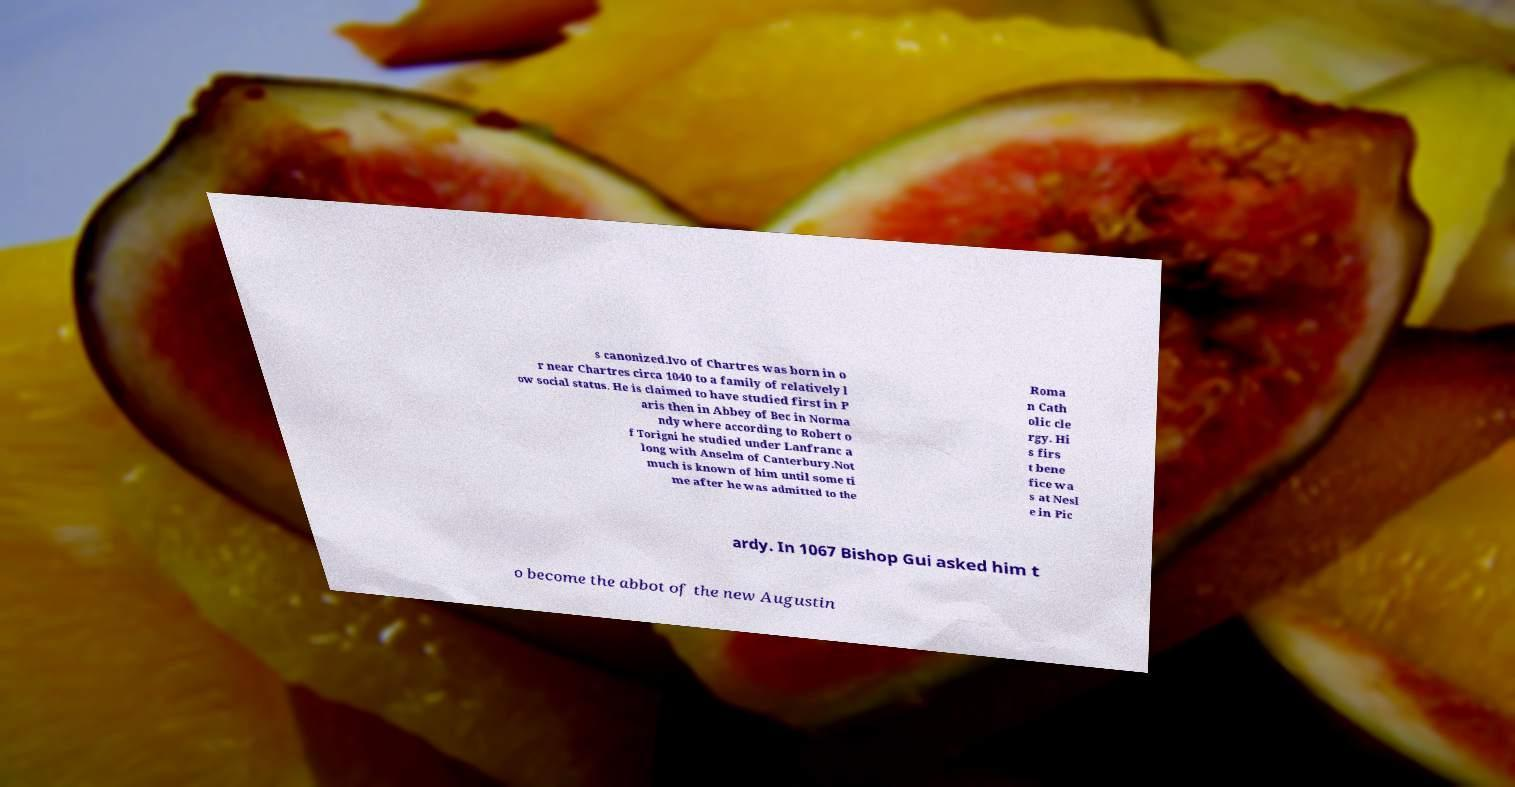Please identify and transcribe the text found in this image. s canonized.Ivo of Chartres was born in o r near Chartres circa 1040 to a family of relatively l ow social status. He is claimed to have studied first in P aris then in Abbey of Bec in Norma ndy where according to Robert o f Torigni he studied under Lanfranc a long with Anselm of Canterbury.Not much is known of him until some ti me after he was admitted to the Roma n Cath olic cle rgy. Hi s firs t bene fice wa s at Nesl e in Pic ardy. In 1067 Bishop Gui asked him t o become the abbot of the new Augustin 